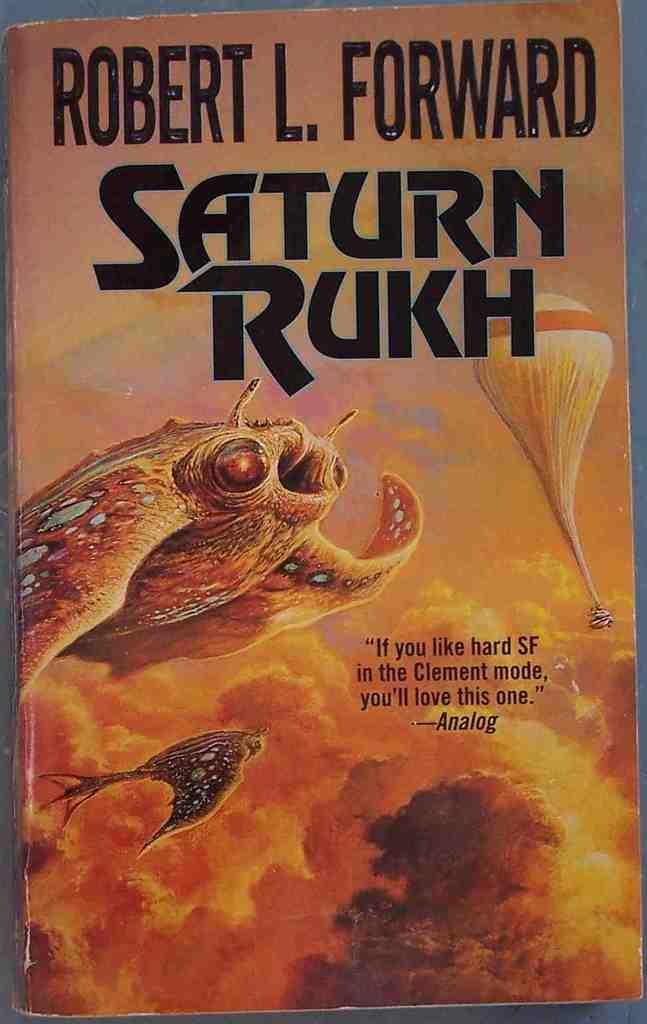Who is the author of this book?
Offer a terse response. Robert l. forward. 